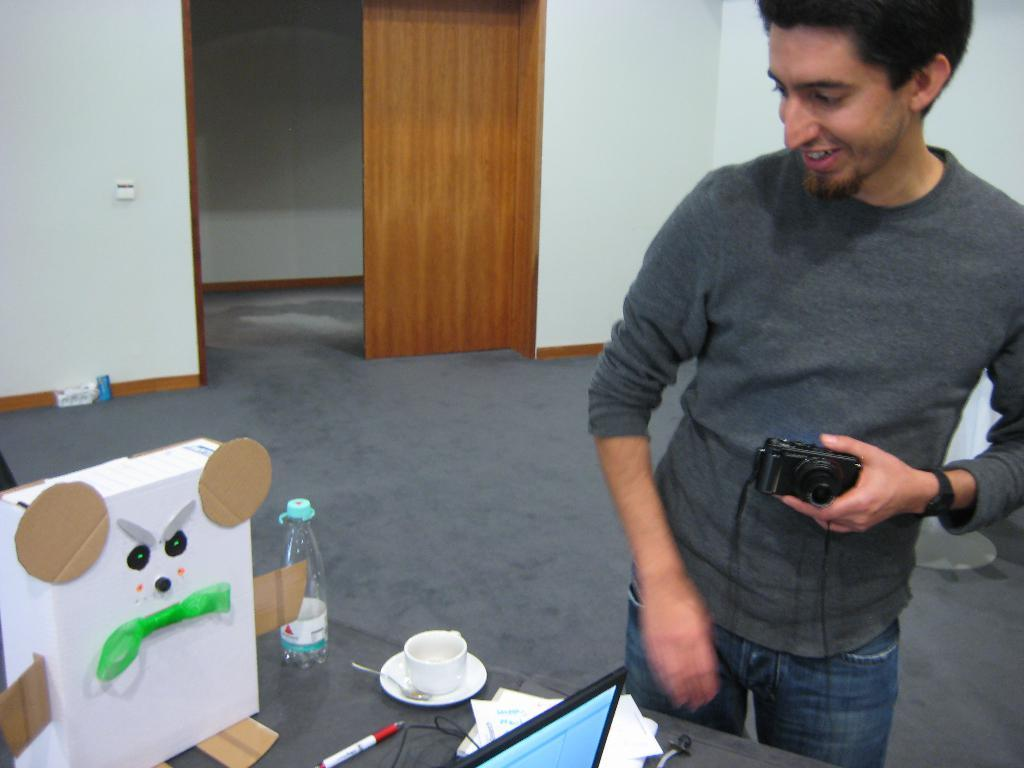What is the man in the image doing? The man is standing with a smile on his face. What is the man holding in his hand? The man is holding a camera in his hand. What objects can be seen on the table in the image? There is a cup, a water bottle, and a laptop on the table. What type of acoustics can be heard in the image? There is no information about any sounds or acoustics in the image. Can you tell me how many bottles are on the table in the image? There is only one water bottle mentioned in the image, not multiple bottles. 